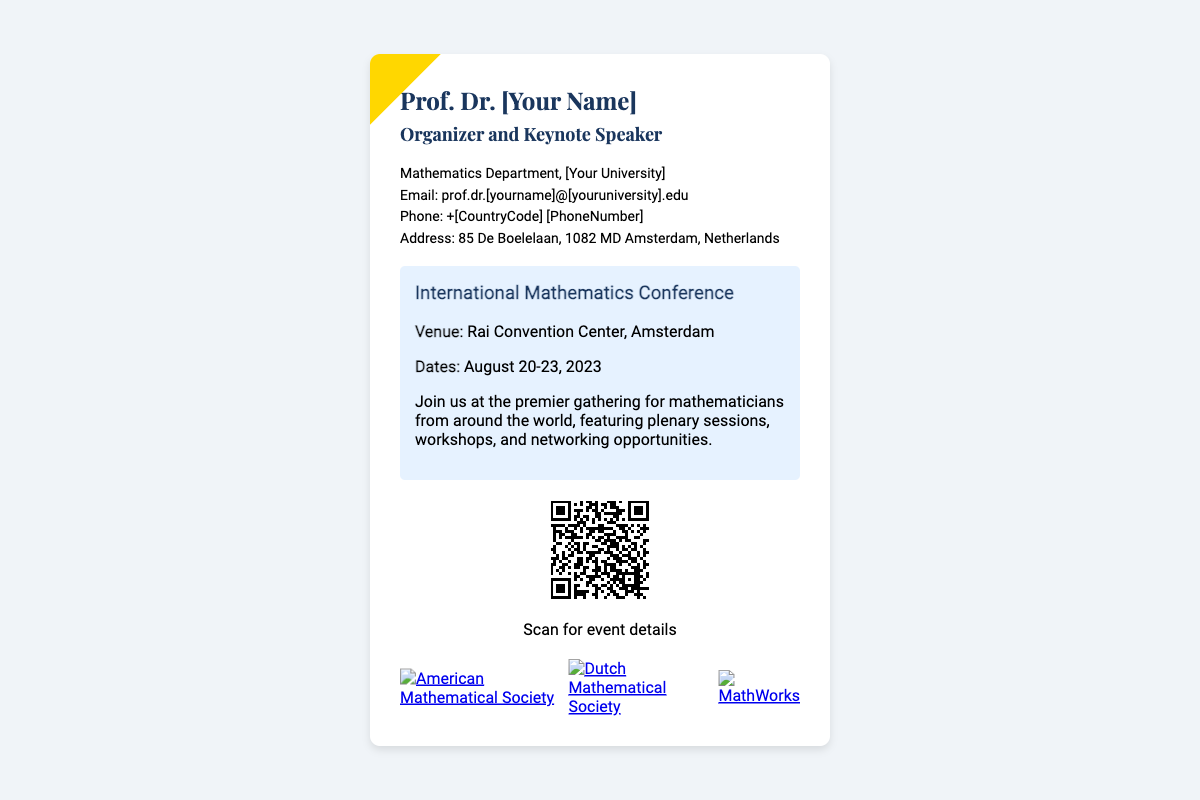What is the name of the organizer? The organizer's name is explicitly mentioned in the card as Prof. Dr. [Your Name].
Answer: Prof. Dr. [Your Name] What is the role of Prof. Dr. [Your Name]? The document states that Prof. Dr. [Your Name] is both an organizer and a keynote speaker for the event.
Answer: Organizer and Keynote Speaker What is the venue of the conference? The venue is listed on the card as Rai Convention Center, Amsterdam.
Answer: Rai Convention Center, Amsterdam What are the dates of the International Mathematics Conference? The dates are provided in the document, indicating that the event occurs from August 20-23, 2023.
Answer: August 20-23, 2023 What department does Prof. Dr. [Your Name] belong to? The card identifies the department as the Mathematics Department at [Your University].
Answer: Mathematics Department, [Your University] How can attendees get more details about the event? The QR code provided in the document can be scanned for additional event details.
Answer: Scan the QR code Who is one of the sponsors listed? The sponsors are illustrated with logos, one of which is the American Mathematical Society.
Answer: American Mathematical Society What is the address of Prof. Dr. [Your Name]? The address is mentioned as 85 De Boelelaan, 1082 MD Amsterdam, Netherlands.
Answer: 85 De Boelelaan, 1082 MD Amsterdam, Netherlands What color scheme is used in the card design? The card prominently features a white background with accents of gold and blue.
Answer: White, gold, and blue 